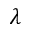Convert formula to latex. <formula><loc_0><loc_0><loc_500><loc_500>\lambda</formula> 